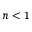Convert formula to latex. <formula><loc_0><loc_0><loc_500><loc_500>n < 1</formula> 